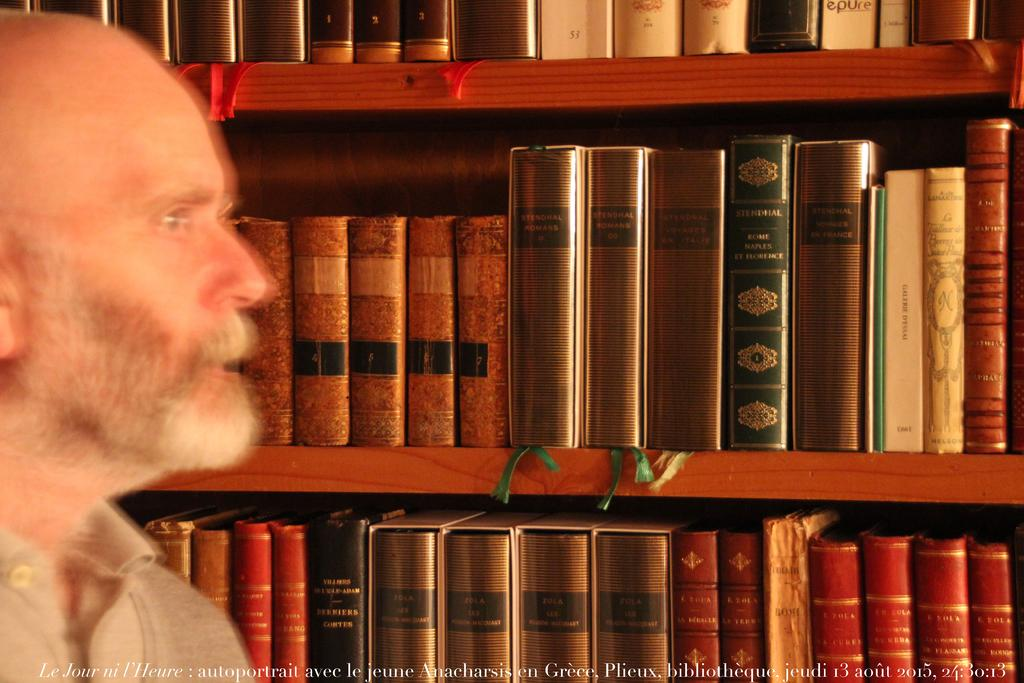What can be seen arranged in racks in the image? There are books arranged in racks in the image. Can you describe the person in the image? There is a person in the image, but their appearance or actions are not specified. What is present at the bottom of the image? There is a watermark at the bottom of the image. What type of cream is being used by the person in the image? There is no person using cream in the image; the person's actions are not specified. What town is depicted in the background of the image? There is no town visible in the image; the focus is on the books and the person. 